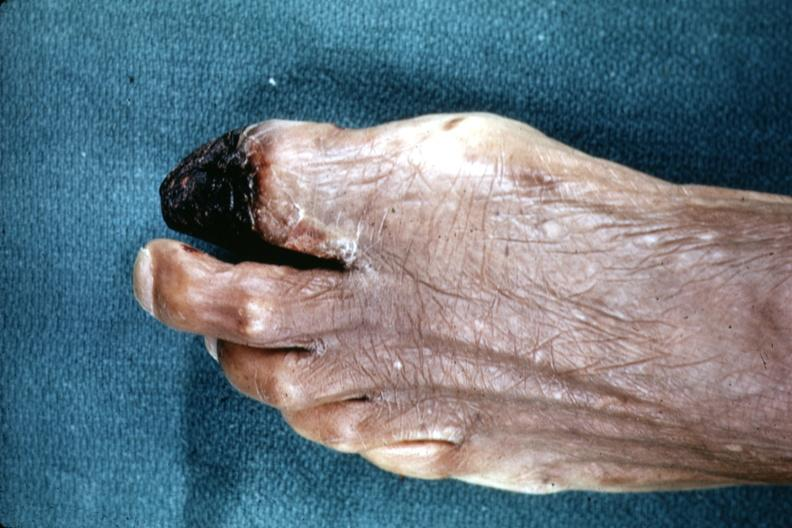what are present?
Answer the question using a single word or phrase. Extremities 